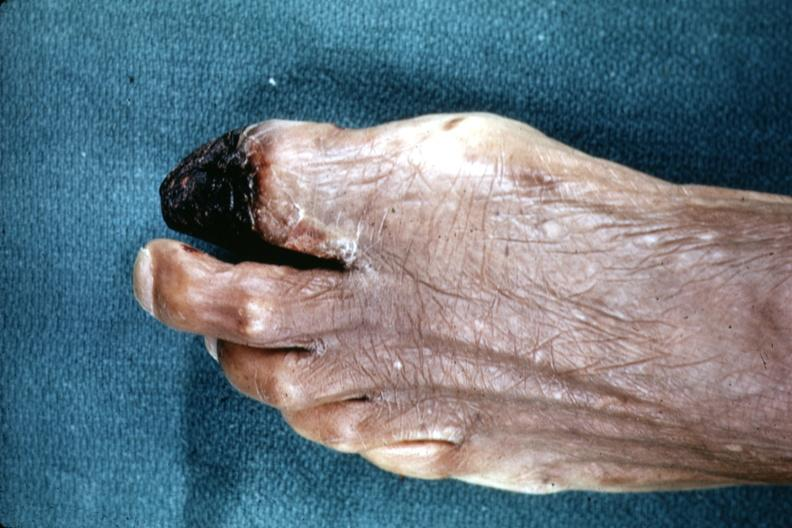what are present?
Answer the question using a single word or phrase. Extremities 